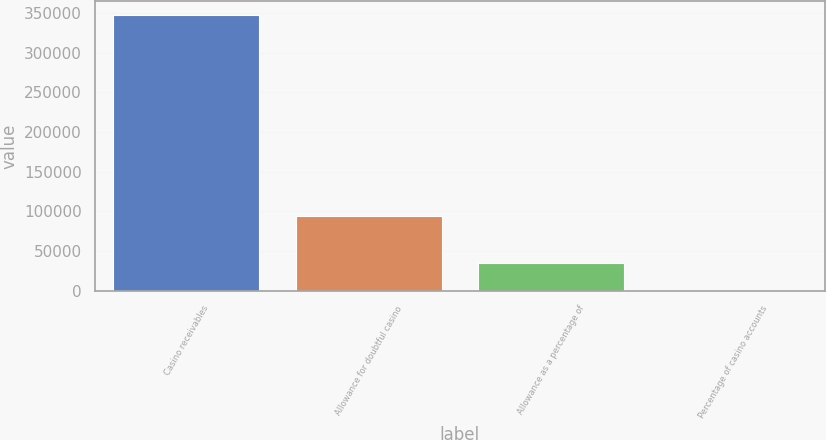Convert chart to OTSL. <chart><loc_0><loc_0><loc_500><loc_500><bar_chart><fcel>Casino receivables<fcel>Allowance for doubtful casino<fcel>Allowance as a percentage of<fcel>Percentage of casino accounts<nl><fcel>347679<fcel>94800<fcel>34784.1<fcel>18<nl></chart> 